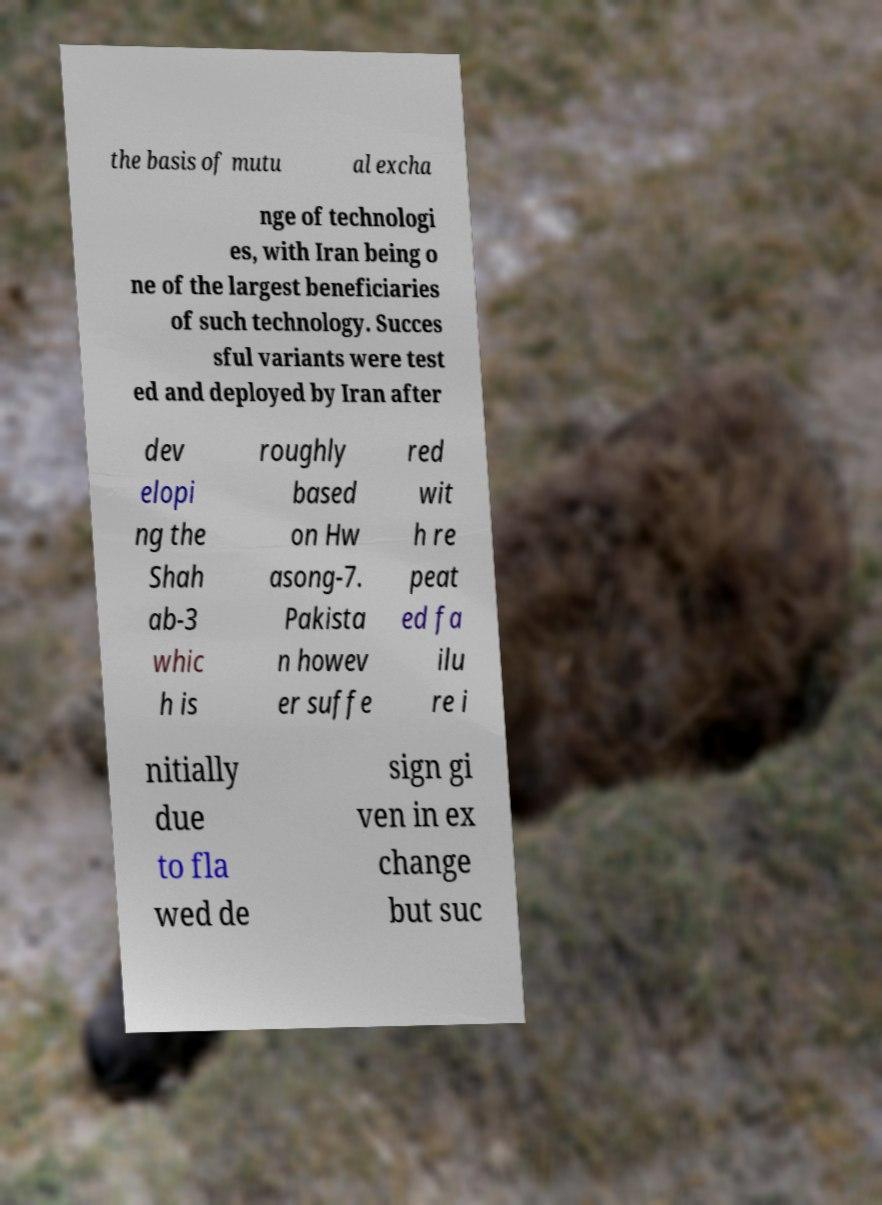There's text embedded in this image that I need extracted. Can you transcribe it verbatim? the basis of mutu al excha nge of technologi es, with Iran being o ne of the largest beneficiaries of such technology. Succes sful variants were test ed and deployed by Iran after dev elopi ng the Shah ab-3 whic h is roughly based on Hw asong-7. Pakista n howev er suffe red wit h re peat ed fa ilu re i nitially due to fla wed de sign gi ven in ex change but suc 